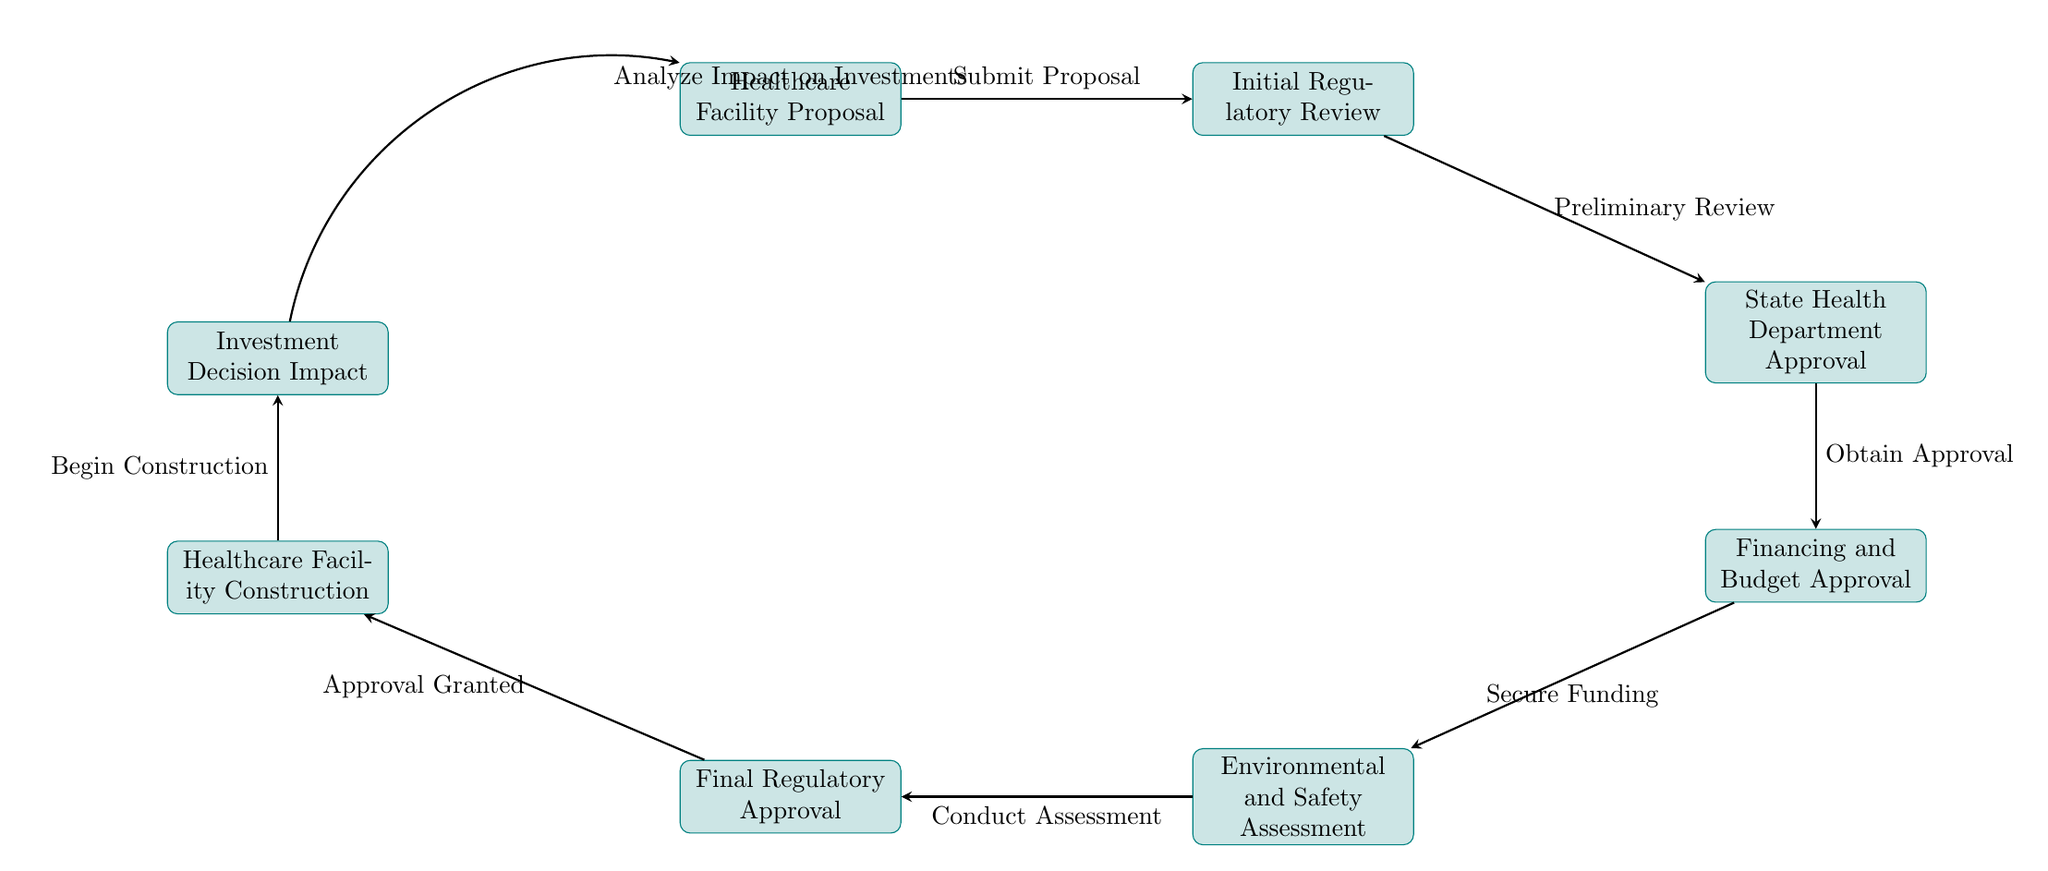What is the first step in the regulatory approval process? The first step in the diagram is represented by the node "Healthcare Facility Proposal," which indicates that submitting a proposal is the initial action in the process.
Answer: Healthcare Facility Proposal How many nodes are in the diagram? By counting each distinct rectangular node in the diagram, there are a total of eight nodes detailing various steps in the regulatory approval process.
Answer: 8 What is the relationship between Initial Regulatory Review and State Health Department Approval? The Initial Regulatory Review node leads to the State Health Department Approval node, indicating that the preliminary review is required before obtaining state approval.
Answer: Preliminary Review What step follows Financing and Budget Approval? According to the diagram, the step that follows Financing and Budget Approval is the Environmental and Safety Assessment, which is necessary for additional approvals.
Answer: Environmental and Safety Assessment What impacts investment decisions according to this flowchart? The flowchart specifies that the "Investment Decision Impact" node summarises the effects of the entire regulatory process on investment decisions, demonstrating how the preceding steps influence financial considerations.
Answer: Analyze Impact on Investments What action must be taken after obtaining State Health Department Approval? After obtaining approval from the state health department, the next action is to secure financing and budget, as indicated by the arrow connecting those nodes.
Answer: Secure Funding Which step is necessary before facility construction can begin? The diagram indicates that prior to facility construction, final regulatory approval must be granted, signifying that all assessments are completed beforehand.
Answer: Approval Granted What node comes before Healthcare Facility Construction? The node that precedes Healthcare Facility Construction is Final Regulatory Approval, which signifies the last required approval before construction can commence.
Answer: Final Regulatory Approval What process comes after the Environmental and Safety Assessment? Following the Environmental and Safety Assessment, the next step is acquiring Final Regulatory Approval, marking the approval stage after assessment completion.
Answer: Final Regulatory Approval How does the diagram loop back to impact analysis? The diagram illustrates that after reaching the "Investment Decision Impact" node, one can analyze how regulatory processes affect investment decisions, thereby creating a feedback loop to the initial proposal.
Answer: Analyze Impact on Investments 